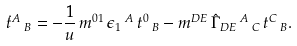<formula> <loc_0><loc_0><loc_500><loc_500>\dot { t } ^ { A } \, _ { B } = - \frac { 1 } { u } \, m ^ { 0 1 } \, \epsilon _ { 1 } \, ^ { A } \, t ^ { 0 } \, _ { B } - m ^ { D E } \, \hat { \Gamma } _ { D E } \, ^ { A } \, _ { C } \, t ^ { C } \, _ { B } .</formula> 